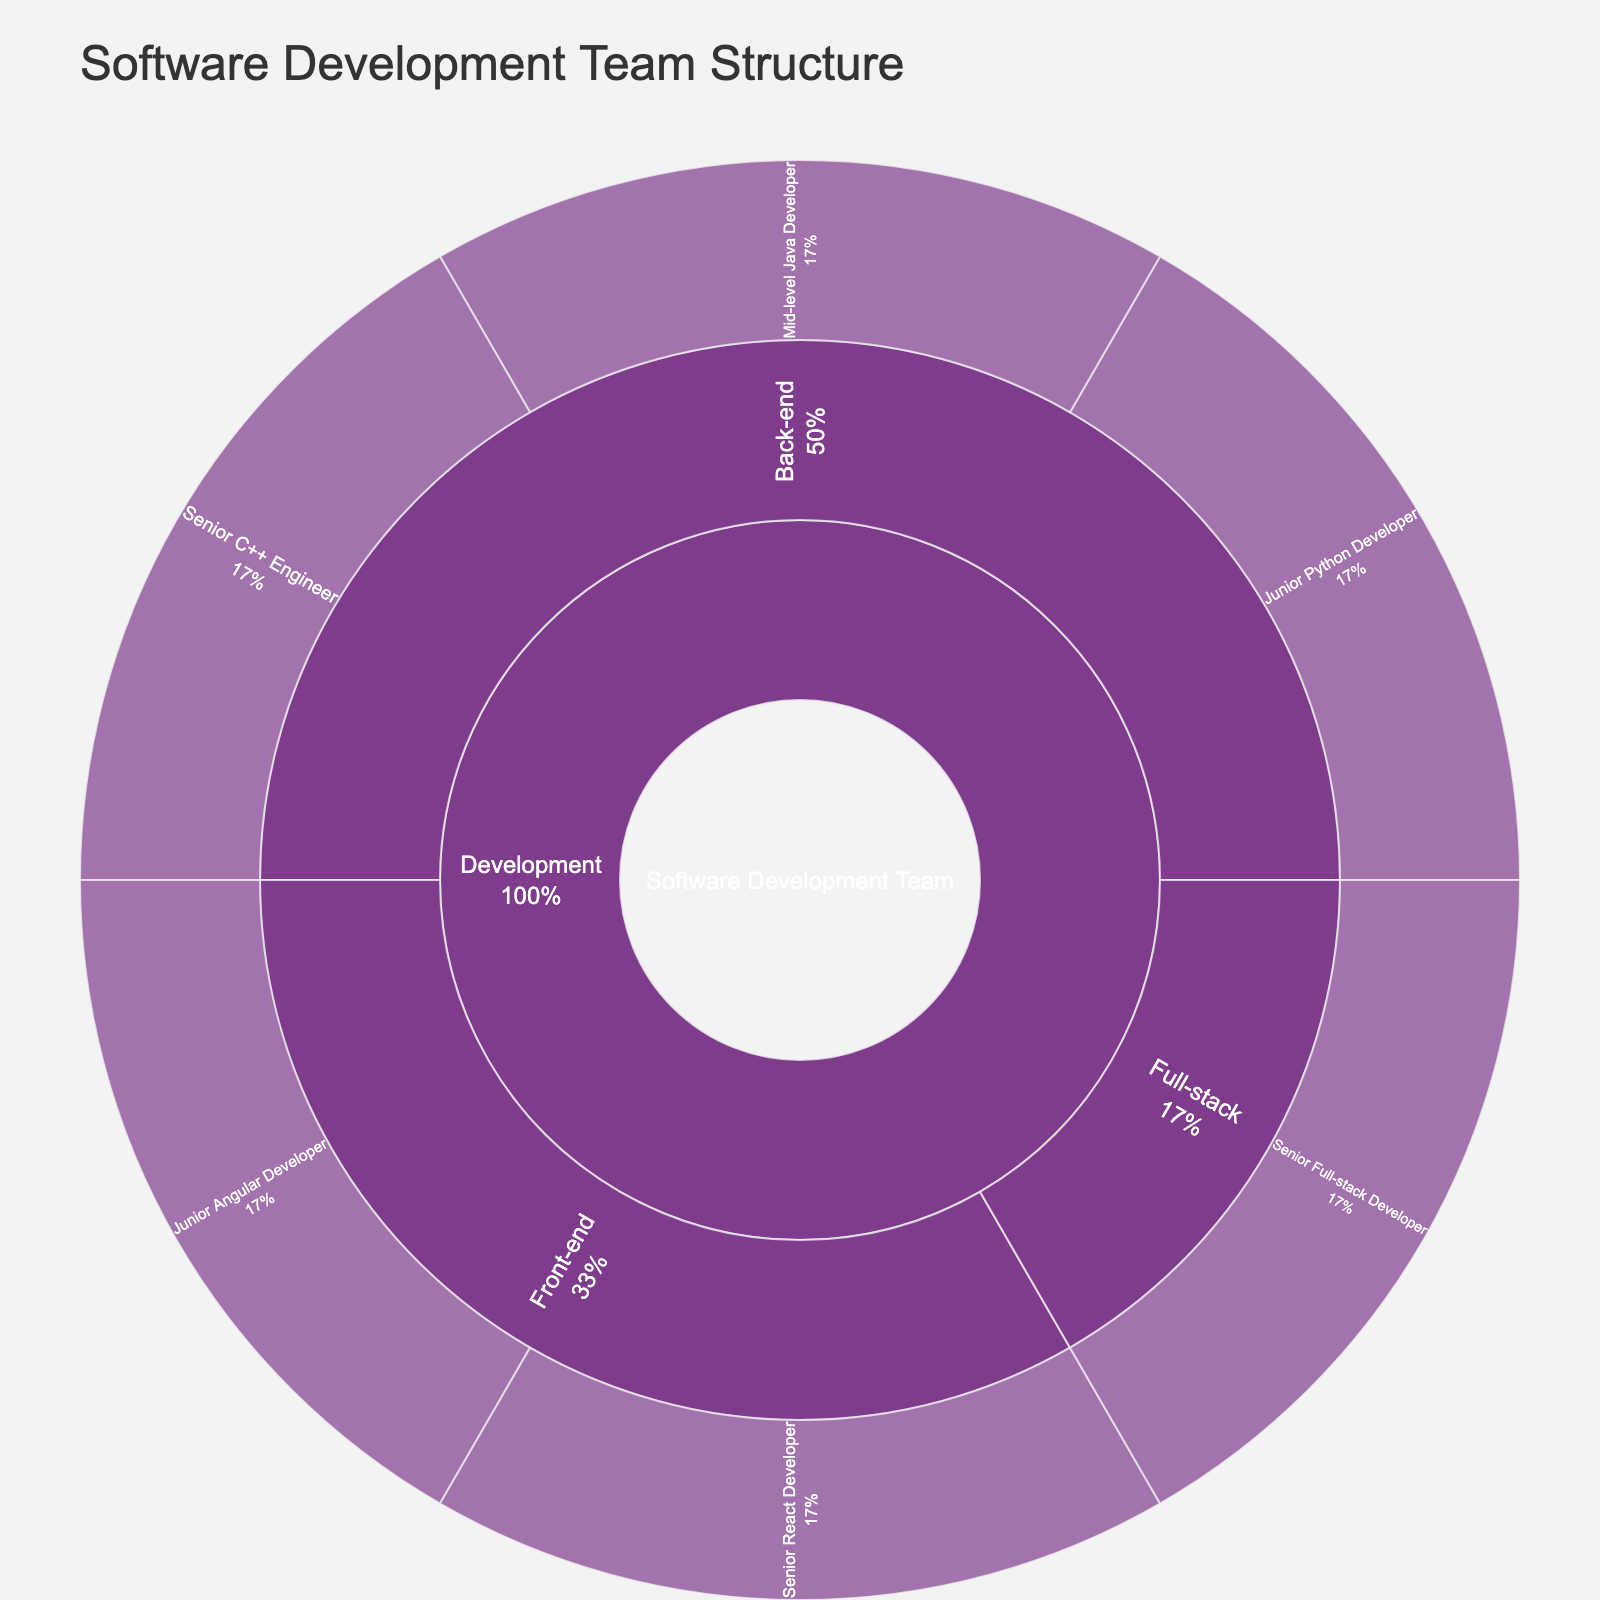What is the title of the figure? The title is always provided at the top of the sunburst plot. In this case, it clearly states what the plot represents.
Answer: Software Development Team Structure What does the color scheme represent? In a sunburst plot, the color scheme typically distinguishes different categories or groups. Here, it differentiates job roles and responsibilities within the software development team.
Answer: Different job roles and specializations How many Senior-level roles are there in the team? By looking at the outermost layer of the sunburst plot, count the segments labeled with "Senior" roles.
Answer: 3 What percentage of the team is involved in Back-end development? The sunburst plot shows the distribution in percentages. Look at the segment "Back-end" and note its percentage from the whole.
Answer: Varies (specific percentage) Which specific roles do Junior team members occupy? Locate the segments labeled "Junior" on the outermost layer of the plot. Identify their respective job roles.
Answer: Junior Angular Developer, Junior Python Developer Compare the number of Front-end developers to Back-end developers. Count the segments under "Front-end" and "Back-end". Compare these counts.
Answer: Less Front-end developers What is the proportion of Full-stack developers compared to the entire team? Find the segment labeled "Full-stack" and note its percentage from the whole team.
Answer: Varies (specific percentage) Which role has exactly one representation in the figure? Identify the role segments with a size of 1, i.e., those with exactly one occurrence.
Answer: Senior Full-stack Developer How many specific job roles are illustrated in the development category? Look at the development segment and count the number of specific job roles listed within this category.
Answer: 6 Is there an equal distribution among different specialization categories? Compare the number of segments and their sizes for Front-end, Back-end, and Full-stack specializations.
Answer: No 